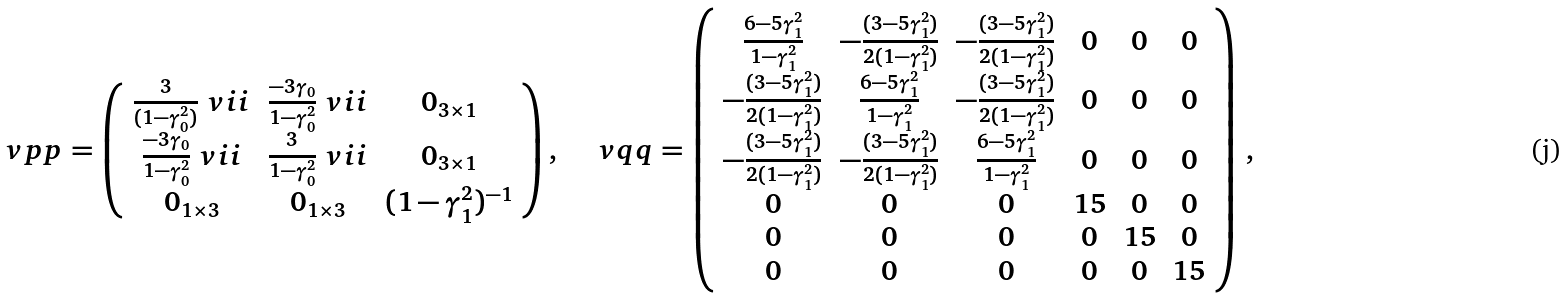Convert formula to latex. <formula><loc_0><loc_0><loc_500><loc_500>\ v p p = \left ( \begin{array} { c c c } \frac { 3 } { ( 1 - \gamma _ { 0 } ^ { 2 } ) } \ v i i & \frac { - 3 \gamma _ { 0 } } { 1 - \gamma _ { 0 } ^ { 2 } } \ v i i & 0 _ { 3 \times 1 } \\ \frac { - 3 \gamma _ { 0 } } { 1 - \gamma _ { 0 } ^ { 2 } } \ v i i & \frac { 3 } { 1 - \gamma _ { 0 } ^ { 2 } } \ v i i & 0 _ { 3 \times 1 } \\ 0 _ { 1 \times 3 } & 0 _ { 1 \times 3 } & ( 1 - \gamma _ { 1 } ^ { 2 } ) ^ { - 1 } \end{array} \right ) , \quad \ v q q = \left ( \begin{array} { c c c c c c } \frac { 6 - 5 \gamma _ { 1 } ^ { 2 } } { 1 - \gamma _ { 1 } ^ { 2 } } & - \frac { ( 3 - 5 \gamma _ { 1 } ^ { 2 } ) } { 2 ( 1 - \gamma _ { 1 } ^ { 2 } ) } & - \frac { ( 3 - 5 \gamma _ { 1 } ^ { 2 } ) } { 2 ( 1 - \gamma _ { 1 } ^ { 2 } ) } & 0 & 0 & 0 \\ - \frac { ( 3 - 5 \gamma _ { 1 } ^ { 2 } ) } { 2 ( 1 - \gamma _ { 1 } ^ { 2 } ) } & \frac { 6 - 5 \gamma _ { 1 } ^ { 2 } } { 1 - \gamma _ { 1 } ^ { 2 } } & - \frac { ( 3 - 5 \gamma _ { 1 } ^ { 2 } ) } { 2 ( 1 - \gamma _ { 1 } ^ { 2 } ) } & 0 & 0 & 0 \\ - \frac { ( 3 - 5 \gamma _ { 1 } ^ { 2 } ) } { 2 ( 1 - \gamma _ { 1 } ^ { 2 } ) } & - \frac { ( 3 - 5 \gamma _ { 1 } ^ { 2 } ) } { 2 ( 1 - \gamma _ { 1 } ^ { 2 } ) } & \frac { 6 - 5 \gamma _ { 1 } ^ { 2 } } { 1 - \gamma _ { 1 } ^ { 2 } } & 0 & 0 & 0 \\ 0 & 0 & 0 & 1 5 & 0 & 0 \\ 0 & 0 & 0 & 0 & 1 5 & 0 \\ 0 & 0 & 0 & 0 & 0 & 1 5 \end{array} \right ) \, ,</formula> 